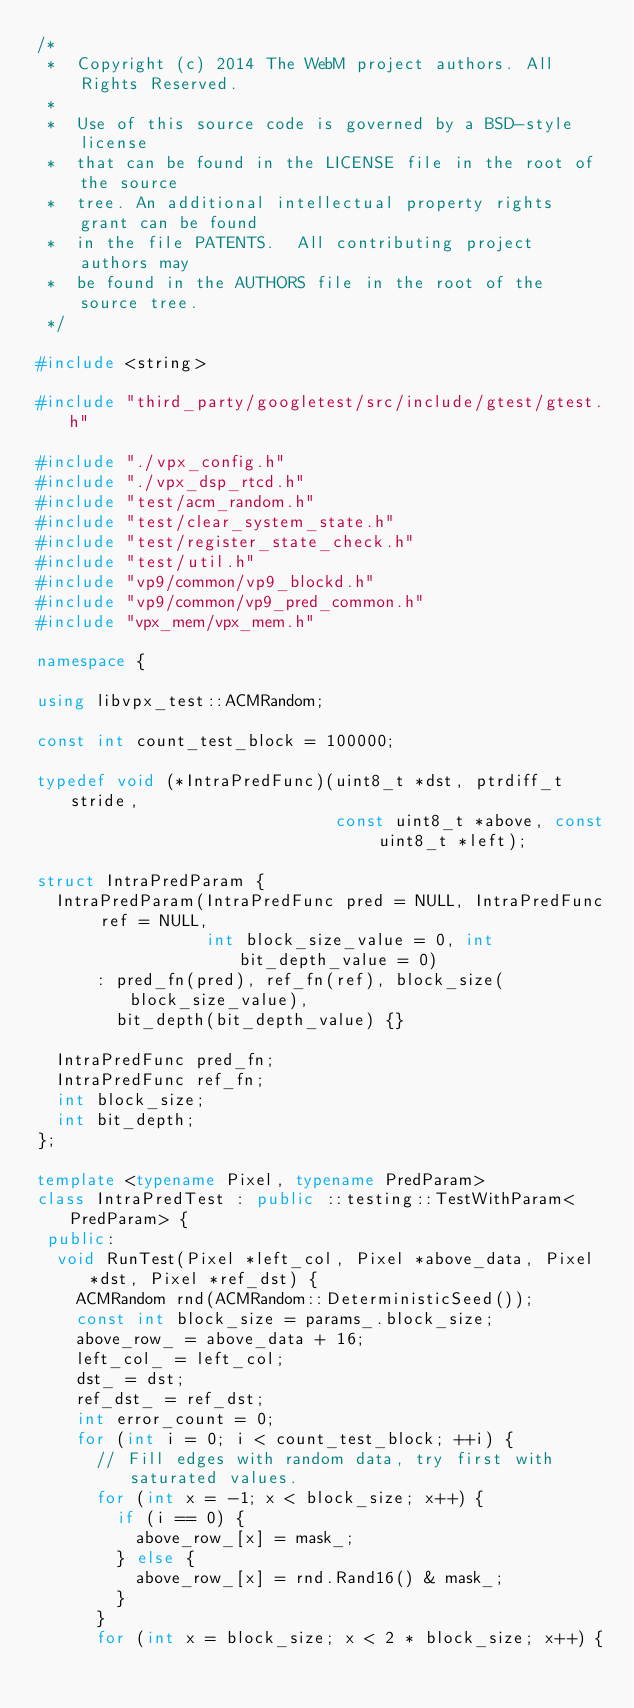Convert code to text. <code><loc_0><loc_0><loc_500><loc_500><_C++_>/*
 *  Copyright (c) 2014 The WebM project authors. All Rights Reserved.
 *
 *  Use of this source code is governed by a BSD-style license
 *  that can be found in the LICENSE file in the root of the source
 *  tree. An additional intellectual property rights grant can be found
 *  in the file PATENTS.  All contributing project authors may
 *  be found in the AUTHORS file in the root of the source tree.
 */

#include <string>

#include "third_party/googletest/src/include/gtest/gtest.h"

#include "./vpx_config.h"
#include "./vpx_dsp_rtcd.h"
#include "test/acm_random.h"
#include "test/clear_system_state.h"
#include "test/register_state_check.h"
#include "test/util.h"
#include "vp9/common/vp9_blockd.h"
#include "vp9/common/vp9_pred_common.h"
#include "vpx_mem/vpx_mem.h"

namespace {

using libvpx_test::ACMRandom;

const int count_test_block = 100000;

typedef void (*IntraPredFunc)(uint8_t *dst, ptrdiff_t stride,
                              const uint8_t *above, const uint8_t *left);

struct IntraPredParam {
  IntraPredParam(IntraPredFunc pred = NULL, IntraPredFunc ref = NULL,
                 int block_size_value = 0, int bit_depth_value = 0)
      : pred_fn(pred), ref_fn(ref), block_size(block_size_value),
        bit_depth(bit_depth_value) {}

  IntraPredFunc pred_fn;
  IntraPredFunc ref_fn;
  int block_size;
  int bit_depth;
};

template <typename Pixel, typename PredParam>
class IntraPredTest : public ::testing::TestWithParam<PredParam> {
 public:
  void RunTest(Pixel *left_col, Pixel *above_data, Pixel *dst, Pixel *ref_dst) {
    ACMRandom rnd(ACMRandom::DeterministicSeed());
    const int block_size = params_.block_size;
    above_row_ = above_data + 16;
    left_col_ = left_col;
    dst_ = dst;
    ref_dst_ = ref_dst;
    int error_count = 0;
    for (int i = 0; i < count_test_block; ++i) {
      // Fill edges with random data, try first with saturated values.
      for (int x = -1; x < block_size; x++) {
        if (i == 0) {
          above_row_[x] = mask_;
        } else {
          above_row_[x] = rnd.Rand16() & mask_;
        }
      }
      for (int x = block_size; x < 2 * block_size; x++) {</code> 